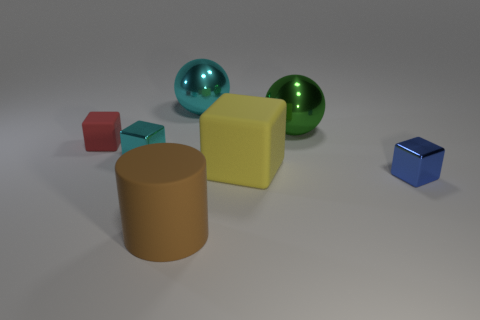Does the blue block have the same size as the matte cylinder in front of the big yellow rubber object?
Offer a very short reply. No. Is the material of the cyan sphere the same as the large cylinder?
Keep it short and to the point. No. What number of metallic spheres are to the left of the large matte cylinder?
Offer a terse response. 0. There is a tiny object that is in front of the red block and on the left side of the blue shiny block; what is it made of?
Ensure brevity in your answer.  Metal. How many blue cubes are the same size as the yellow cube?
Your response must be concise. 0. What color is the tiny metal cube right of the small shiny cube that is on the left side of the big brown thing?
Provide a succinct answer. Blue. Are any small matte spheres visible?
Offer a terse response. No. Is the shape of the large cyan object the same as the big green object?
Keep it short and to the point. Yes. What number of small things are to the right of the metal ball that is left of the big yellow rubber thing?
Give a very brief answer. 1. What number of objects are in front of the green metal thing and on the left side of the yellow thing?
Keep it short and to the point. 3. 